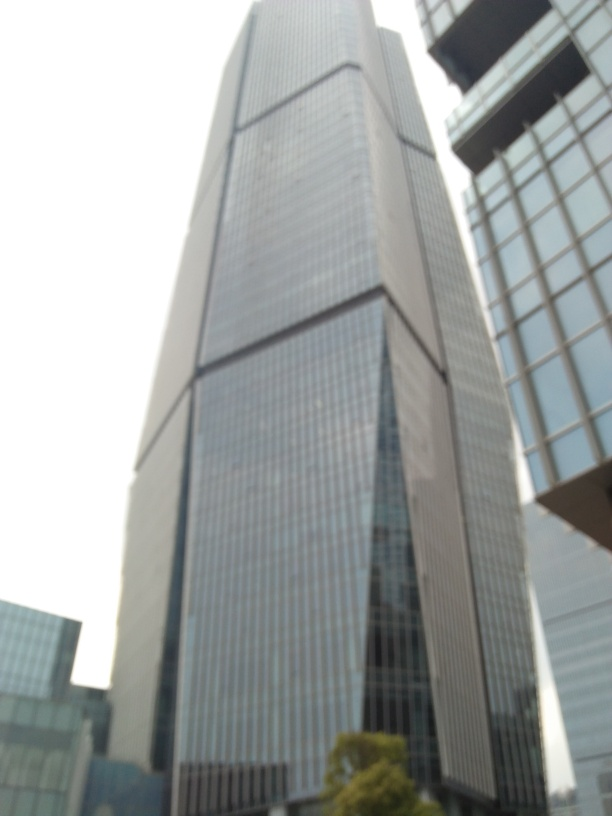Does the photo have natural colors? The photo appears to have a slight overexposure which makes the colors look washed out and reduces the contrast. This gives an unnatural coloration to the image of the building. Enhancing the photo with photo editing software could restore some of the natural colors. 